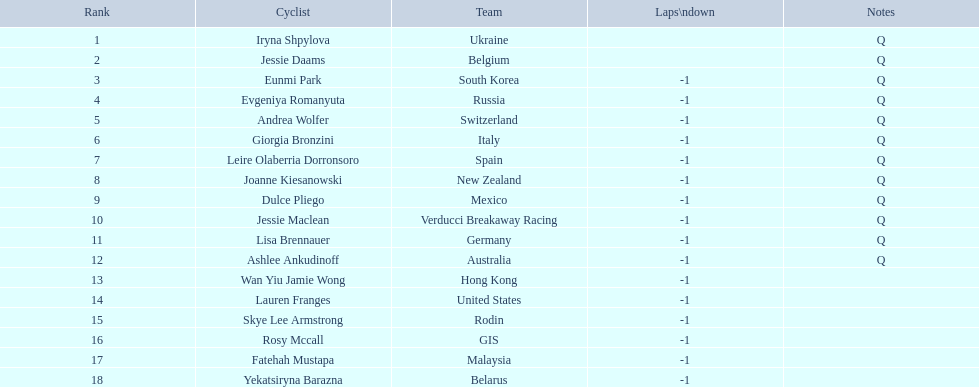Who is the last cyclist listed? Yekatsiryna Barazna. 